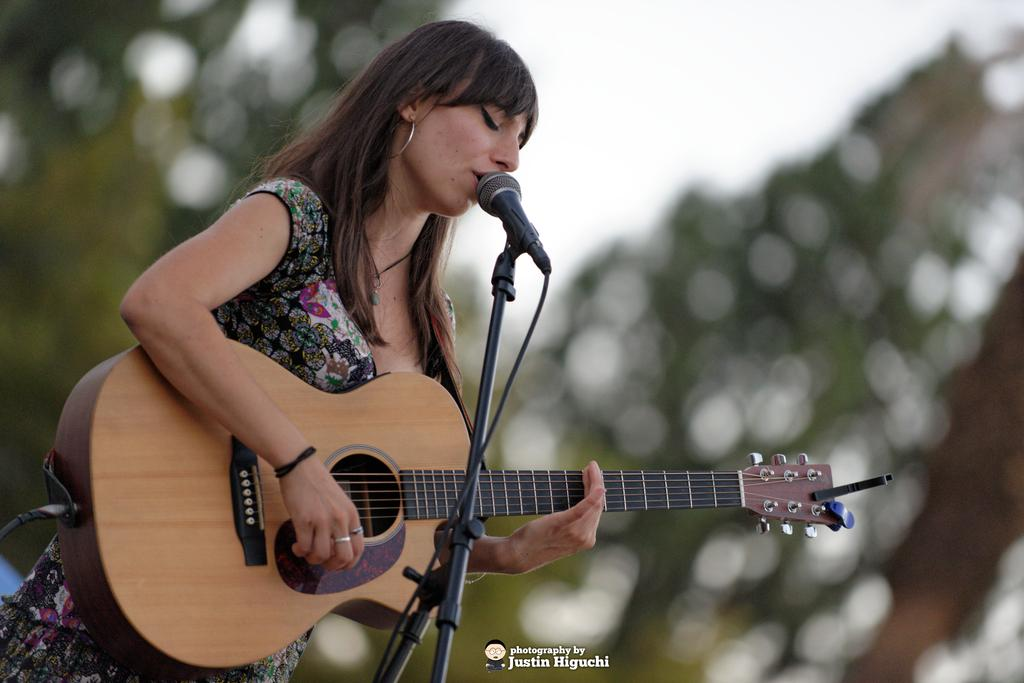Who is the main subject in the image? There is a woman in the image. What is the woman doing in the image? The woman is singing and playing a guitar. What object is the woman holding in the image? The woman is holding a microphone. What route does the woman take to beginner level in the image? There is no indication of a route or beginner level in the image; it simply shows a woman singing and playing a guitar. 